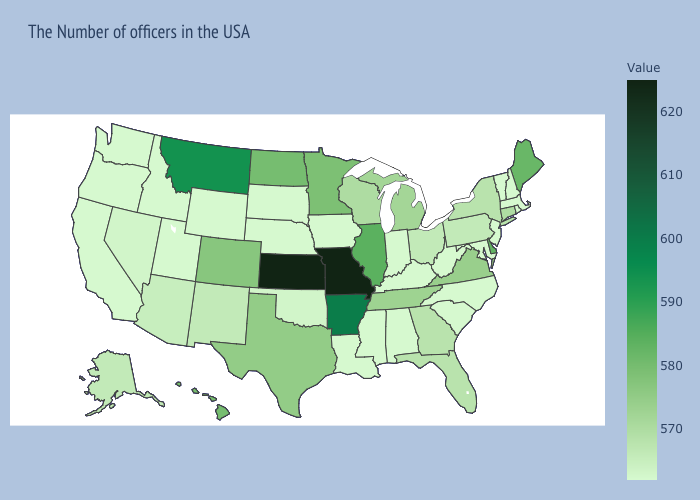Which states have the lowest value in the USA?
Be succinct. Massachusetts, Rhode Island, New Hampshire, Vermont, New Jersey, Maryland, North Carolina, South Carolina, West Virginia, Kentucky, Indiana, Alabama, Mississippi, Louisiana, Iowa, Nebraska, South Dakota, Wyoming, Utah, Idaho, California, Washington, Oregon. Among the states that border North Dakota , does Minnesota have the highest value?
Short answer required. No. Does Nebraska have the lowest value in the MidWest?
Concise answer only. Yes. Which states hav the highest value in the Northeast?
Give a very brief answer. Maine. Among the states that border Arkansas , which have the lowest value?
Quick response, please. Mississippi, Louisiana. Does Mississippi have the lowest value in the South?
Write a very short answer. Yes. Does Missouri have the highest value in the USA?
Keep it brief. Yes. Among the states that border Virginia , which have the lowest value?
Short answer required. Maryland, North Carolina, West Virginia, Kentucky. Does Washington have the lowest value in the West?
Be succinct. Yes. 